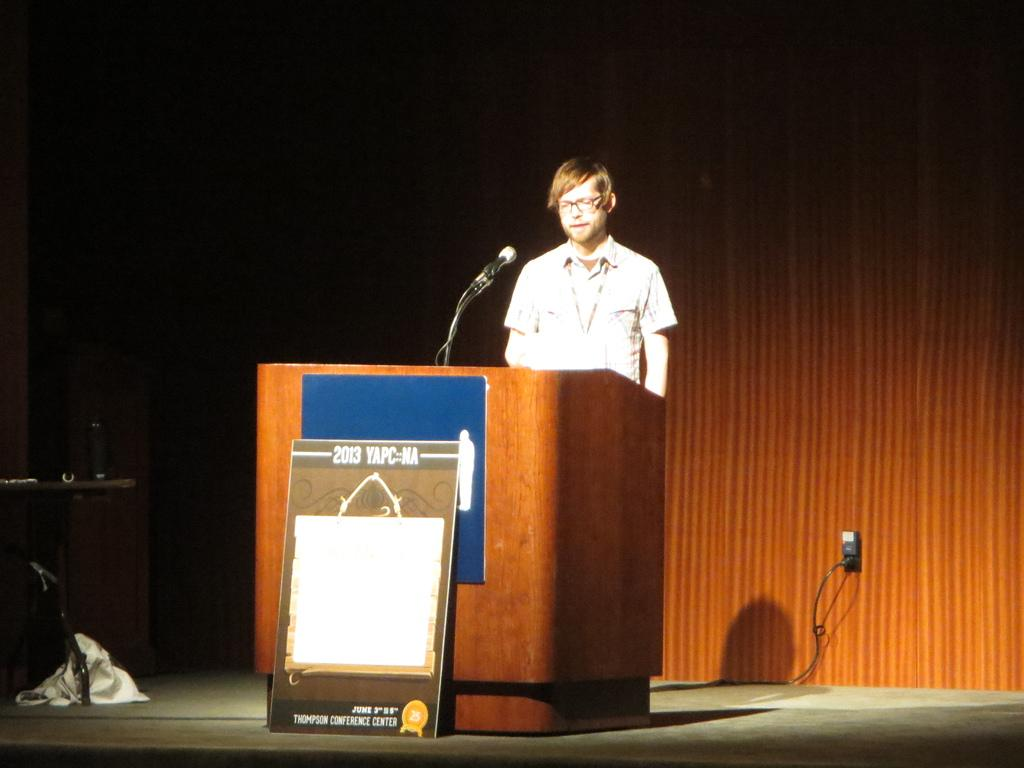What is the person in the image doing? The person is standing on the stage. What object is the person near on the stage? The person is near a podium. What device is present for amplifying the person's voice? There is a microphone in the image. What type of objects can be seen in the image besides the person and the podium? There are boards and a table in the image. What is placed on the table in the image? There is a speaker on the table. What type of bells can be heard ringing in the image? There are no bells present in the image, and therefore no sound can be heard. 